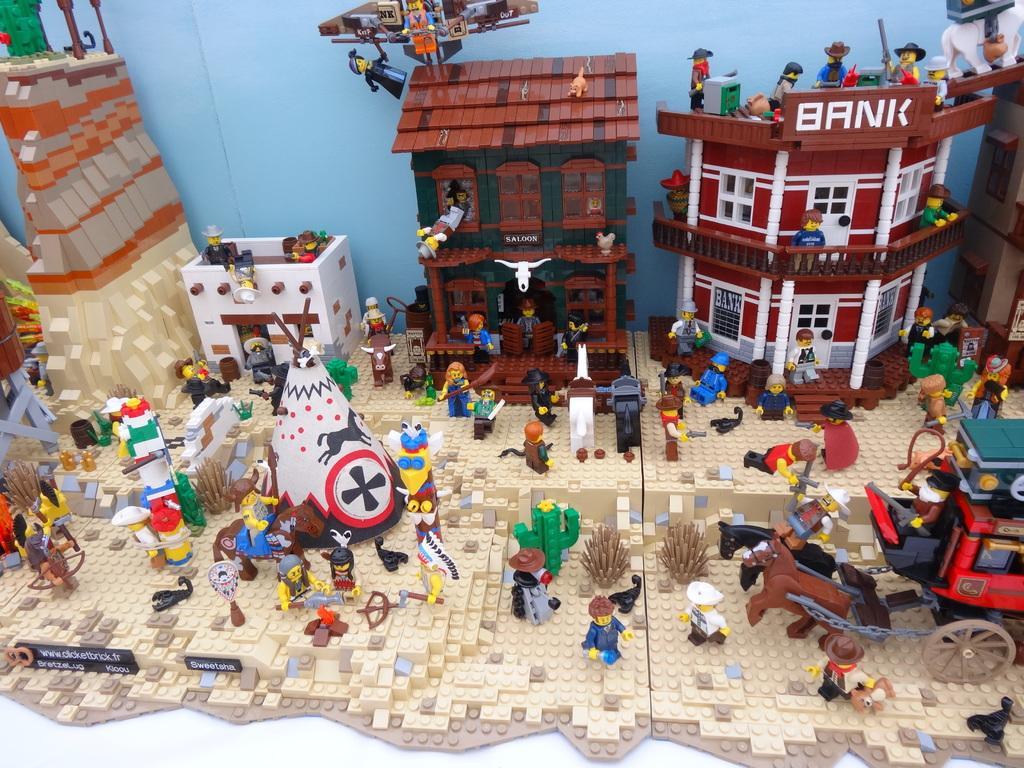Describe this image in one or two sentences. This is the LEGO puzzle. I can see a horse cart. This is the building with windows. I can see a small house. There are few people standing and few people walking. This looks like a bank as on the board. These are the plants. I can see an animal walking. 